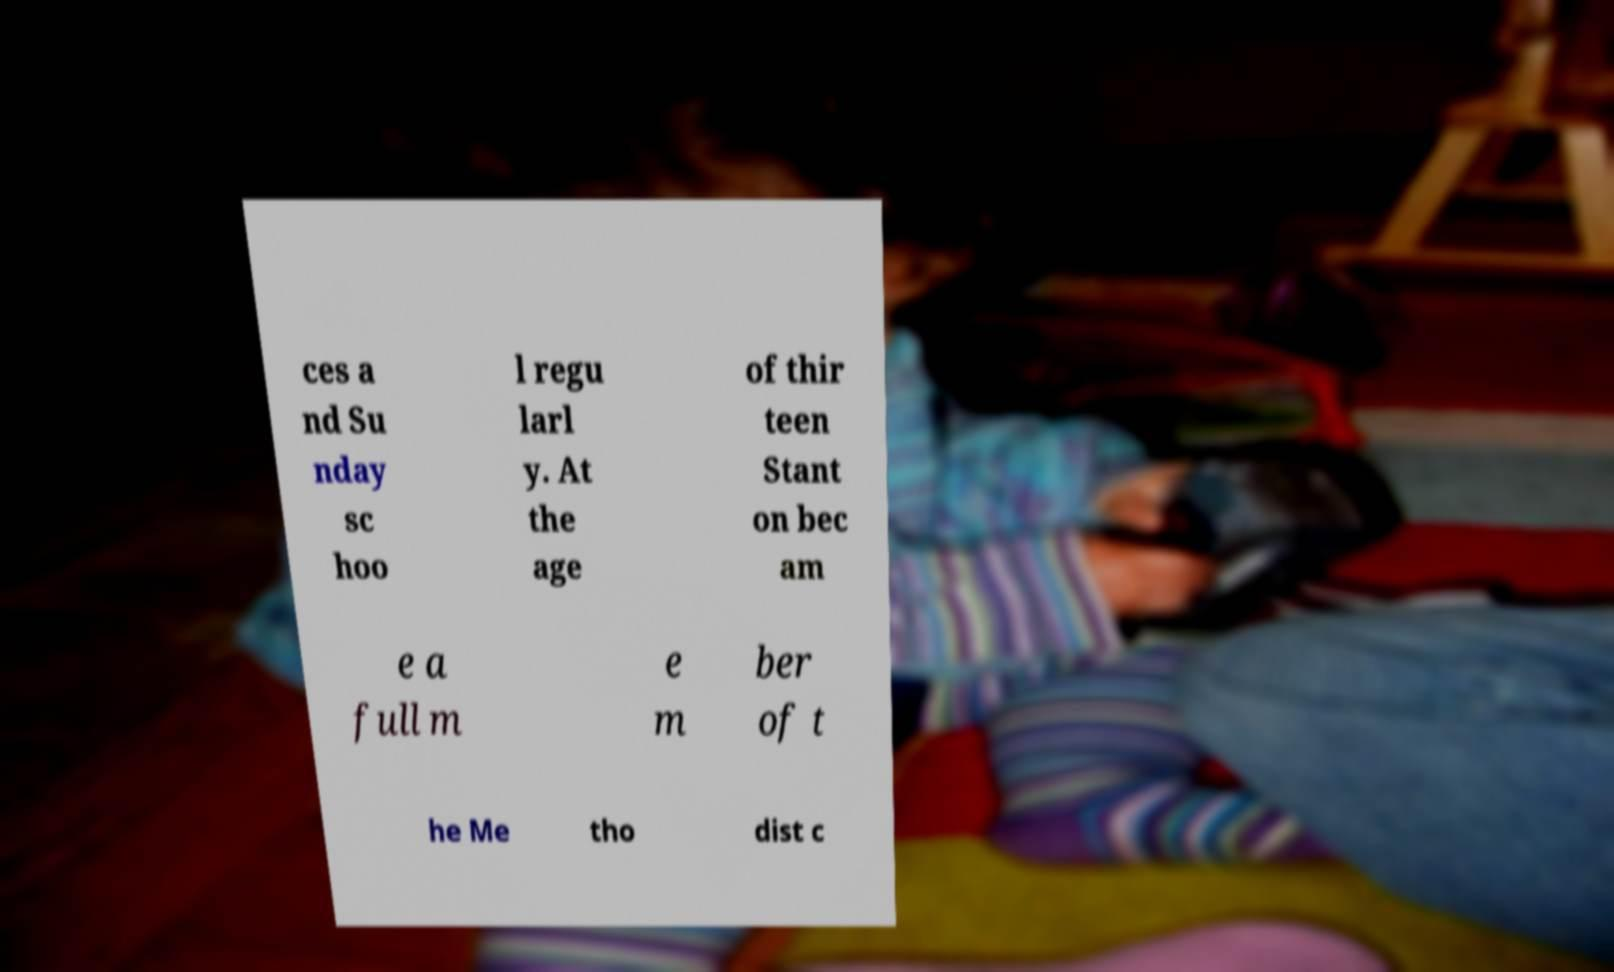There's text embedded in this image that I need extracted. Can you transcribe it verbatim? ces a nd Su nday sc hoo l regu larl y. At the age of thir teen Stant on bec am e a full m e m ber of t he Me tho dist c 